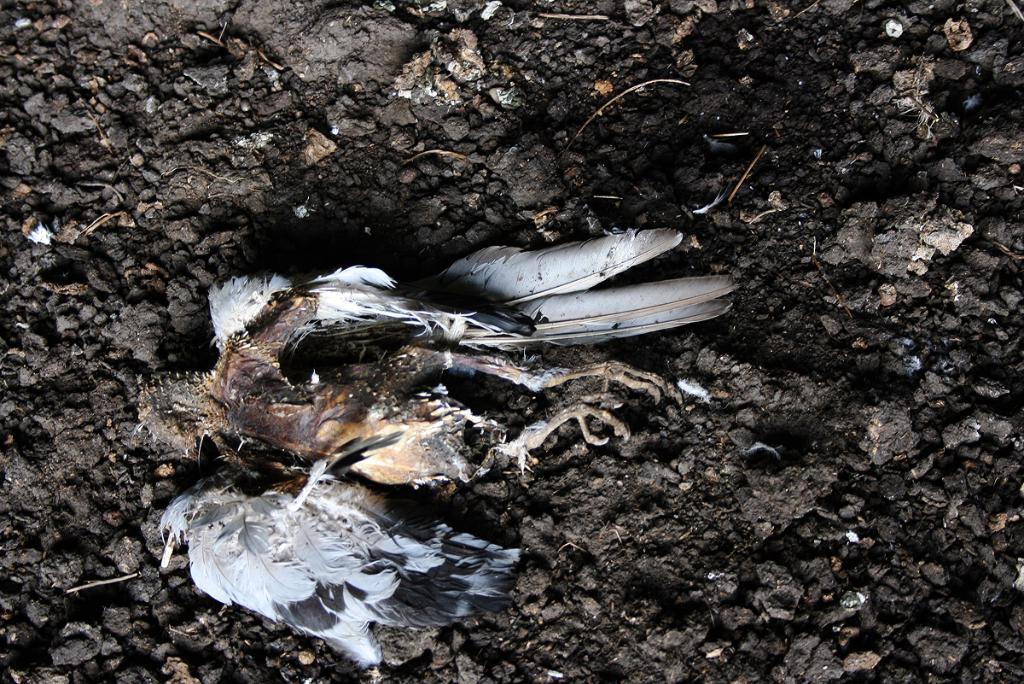In one or two sentences, can you explain what this image depicts? The picture consists of a dead bird in black soil. 